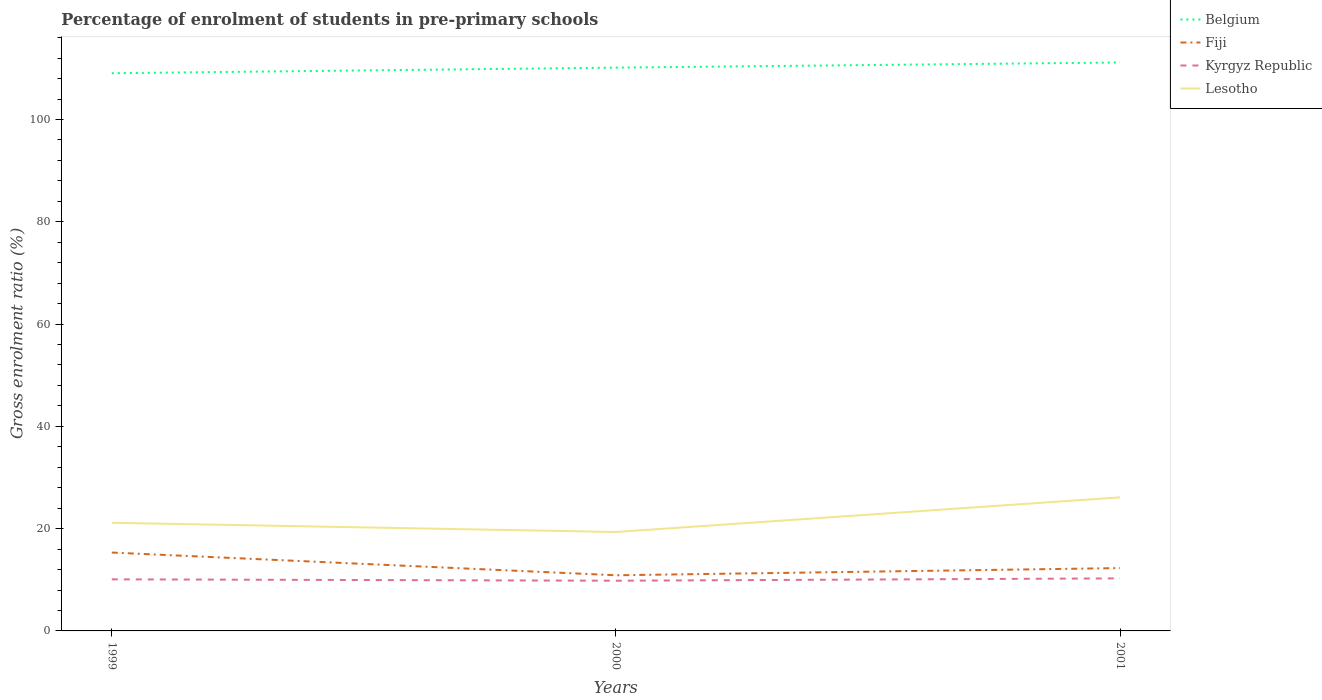How many different coloured lines are there?
Your response must be concise. 4. Is the number of lines equal to the number of legend labels?
Offer a terse response. Yes. Across all years, what is the maximum percentage of students enrolled in pre-primary schools in Lesotho?
Keep it short and to the point. 19.34. In which year was the percentage of students enrolled in pre-primary schools in Belgium maximum?
Your answer should be very brief. 1999. What is the total percentage of students enrolled in pre-primary schools in Fiji in the graph?
Provide a succinct answer. -1.41. What is the difference between the highest and the second highest percentage of students enrolled in pre-primary schools in Kyrgyz Republic?
Make the answer very short. 0.46. What is the difference between the highest and the lowest percentage of students enrolled in pre-primary schools in Lesotho?
Your answer should be very brief. 1. Is the percentage of students enrolled in pre-primary schools in Belgium strictly greater than the percentage of students enrolled in pre-primary schools in Fiji over the years?
Keep it short and to the point. No. How many lines are there?
Ensure brevity in your answer.  4. What is the difference between two consecutive major ticks on the Y-axis?
Provide a short and direct response. 20. Are the values on the major ticks of Y-axis written in scientific E-notation?
Offer a very short reply. No. How many legend labels are there?
Your response must be concise. 4. What is the title of the graph?
Your response must be concise. Percentage of enrolment of students in pre-primary schools. Does "Hong Kong" appear as one of the legend labels in the graph?
Your answer should be very brief. No. What is the label or title of the Y-axis?
Provide a succinct answer. Gross enrolment ratio (%). What is the Gross enrolment ratio (%) in Belgium in 1999?
Offer a terse response. 109.05. What is the Gross enrolment ratio (%) of Fiji in 1999?
Your answer should be very brief. 15.32. What is the Gross enrolment ratio (%) of Kyrgyz Republic in 1999?
Your response must be concise. 10.09. What is the Gross enrolment ratio (%) of Lesotho in 1999?
Provide a short and direct response. 21.15. What is the Gross enrolment ratio (%) of Belgium in 2000?
Give a very brief answer. 110.14. What is the Gross enrolment ratio (%) of Fiji in 2000?
Your answer should be compact. 10.88. What is the Gross enrolment ratio (%) of Kyrgyz Republic in 2000?
Provide a succinct answer. 9.82. What is the Gross enrolment ratio (%) in Lesotho in 2000?
Offer a terse response. 19.34. What is the Gross enrolment ratio (%) of Belgium in 2001?
Your answer should be very brief. 111.14. What is the Gross enrolment ratio (%) in Fiji in 2001?
Make the answer very short. 12.29. What is the Gross enrolment ratio (%) of Kyrgyz Republic in 2001?
Your answer should be very brief. 10.28. What is the Gross enrolment ratio (%) of Lesotho in 2001?
Your response must be concise. 26.12. Across all years, what is the maximum Gross enrolment ratio (%) in Belgium?
Keep it short and to the point. 111.14. Across all years, what is the maximum Gross enrolment ratio (%) of Fiji?
Your answer should be compact. 15.32. Across all years, what is the maximum Gross enrolment ratio (%) in Kyrgyz Republic?
Offer a very short reply. 10.28. Across all years, what is the maximum Gross enrolment ratio (%) of Lesotho?
Your response must be concise. 26.12. Across all years, what is the minimum Gross enrolment ratio (%) in Belgium?
Provide a short and direct response. 109.05. Across all years, what is the minimum Gross enrolment ratio (%) in Fiji?
Your response must be concise. 10.88. Across all years, what is the minimum Gross enrolment ratio (%) of Kyrgyz Republic?
Keep it short and to the point. 9.82. Across all years, what is the minimum Gross enrolment ratio (%) in Lesotho?
Provide a short and direct response. 19.34. What is the total Gross enrolment ratio (%) in Belgium in the graph?
Provide a succinct answer. 330.33. What is the total Gross enrolment ratio (%) in Fiji in the graph?
Give a very brief answer. 38.49. What is the total Gross enrolment ratio (%) of Kyrgyz Republic in the graph?
Your answer should be compact. 30.18. What is the total Gross enrolment ratio (%) in Lesotho in the graph?
Provide a succinct answer. 66.6. What is the difference between the Gross enrolment ratio (%) of Belgium in 1999 and that in 2000?
Ensure brevity in your answer.  -1.09. What is the difference between the Gross enrolment ratio (%) of Fiji in 1999 and that in 2000?
Give a very brief answer. 4.44. What is the difference between the Gross enrolment ratio (%) of Kyrgyz Republic in 1999 and that in 2000?
Your response must be concise. 0.27. What is the difference between the Gross enrolment ratio (%) of Lesotho in 1999 and that in 2000?
Give a very brief answer. 1.8. What is the difference between the Gross enrolment ratio (%) of Belgium in 1999 and that in 2001?
Make the answer very short. -2.1. What is the difference between the Gross enrolment ratio (%) in Fiji in 1999 and that in 2001?
Ensure brevity in your answer.  3.04. What is the difference between the Gross enrolment ratio (%) of Kyrgyz Republic in 1999 and that in 2001?
Offer a terse response. -0.19. What is the difference between the Gross enrolment ratio (%) in Lesotho in 1999 and that in 2001?
Make the answer very short. -4.97. What is the difference between the Gross enrolment ratio (%) of Belgium in 2000 and that in 2001?
Your answer should be very brief. -1.01. What is the difference between the Gross enrolment ratio (%) in Fiji in 2000 and that in 2001?
Your answer should be very brief. -1.41. What is the difference between the Gross enrolment ratio (%) in Kyrgyz Republic in 2000 and that in 2001?
Make the answer very short. -0.46. What is the difference between the Gross enrolment ratio (%) in Lesotho in 2000 and that in 2001?
Your response must be concise. -6.77. What is the difference between the Gross enrolment ratio (%) in Belgium in 1999 and the Gross enrolment ratio (%) in Fiji in 2000?
Give a very brief answer. 98.16. What is the difference between the Gross enrolment ratio (%) in Belgium in 1999 and the Gross enrolment ratio (%) in Kyrgyz Republic in 2000?
Your response must be concise. 99.23. What is the difference between the Gross enrolment ratio (%) in Belgium in 1999 and the Gross enrolment ratio (%) in Lesotho in 2000?
Keep it short and to the point. 89.7. What is the difference between the Gross enrolment ratio (%) of Fiji in 1999 and the Gross enrolment ratio (%) of Kyrgyz Republic in 2000?
Make the answer very short. 5.51. What is the difference between the Gross enrolment ratio (%) of Fiji in 1999 and the Gross enrolment ratio (%) of Lesotho in 2000?
Offer a very short reply. -4.02. What is the difference between the Gross enrolment ratio (%) in Kyrgyz Republic in 1999 and the Gross enrolment ratio (%) in Lesotho in 2000?
Give a very brief answer. -9.25. What is the difference between the Gross enrolment ratio (%) of Belgium in 1999 and the Gross enrolment ratio (%) of Fiji in 2001?
Give a very brief answer. 96.76. What is the difference between the Gross enrolment ratio (%) of Belgium in 1999 and the Gross enrolment ratio (%) of Kyrgyz Republic in 2001?
Provide a succinct answer. 98.77. What is the difference between the Gross enrolment ratio (%) of Belgium in 1999 and the Gross enrolment ratio (%) of Lesotho in 2001?
Provide a succinct answer. 82.93. What is the difference between the Gross enrolment ratio (%) in Fiji in 1999 and the Gross enrolment ratio (%) in Kyrgyz Republic in 2001?
Your response must be concise. 5.05. What is the difference between the Gross enrolment ratio (%) in Fiji in 1999 and the Gross enrolment ratio (%) in Lesotho in 2001?
Ensure brevity in your answer.  -10.79. What is the difference between the Gross enrolment ratio (%) in Kyrgyz Republic in 1999 and the Gross enrolment ratio (%) in Lesotho in 2001?
Your answer should be very brief. -16.03. What is the difference between the Gross enrolment ratio (%) in Belgium in 2000 and the Gross enrolment ratio (%) in Fiji in 2001?
Offer a terse response. 97.85. What is the difference between the Gross enrolment ratio (%) in Belgium in 2000 and the Gross enrolment ratio (%) in Kyrgyz Republic in 2001?
Your answer should be very brief. 99.86. What is the difference between the Gross enrolment ratio (%) of Belgium in 2000 and the Gross enrolment ratio (%) of Lesotho in 2001?
Give a very brief answer. 84.02. What is the difference between the Gross enrolment ratio (%) of Fiji in 2000 and the Gross enrolment ratio (%) of Kyrgyz Republic in 2001?
Give a very brief answer. 0.6. What is the difference between the Gross enrolment ratio (%) in Fiji in 2000 and the Gross enrolment ratio (%) in Lesotho in 2001?
Ensure brevity in your answer.  -15.23. What is the difference between the Gross enrolment ratio (%) in Kyrgyz Republic in 2000 and the Gross enrolment ratio (%) in Lesotho in 2001?
Keep it short and to the point. -16.3. What is the average Gross enrolment ratio (%) of Belgium per year?
Offer a terse response. 110.11. What is the average Gross enrolment ratio (%) of Fiji per year?
Keep it short and to the point. 12.83. What is the average Gross enrolment ratio (%) in Kyrgyz Republic per year?
Provide a succinct answer. 10.06. What is the average Gross enrolment ratio (%) in Lesotho per year?
Ensure brevity in your answer.  22.2. In the year 1999, what is the difference between the Gross enrolment ratio (%) in Belgium and Gross enrolment ratio (%) in Fiji?
Offer a terse response. 93.72. In the year 1999, what is the difference between the Gross enrolment ratio (%) in Belgium and Gross enrolment ratio (%) in Kyrgyz Republic?
Offer a very short reply. 98.96. In the year 1999, what is the difference between the Gross enrolment ratio (%) of Belgium and Gross enrolment ratio (%) of Lesotho?
Your answer should be very brief. 87.9. In the year 1999, what is the difference between the Gross enrolment ratio (%) in Fiji and Gross enrolment ratio (%) in Kyrgyz Republic?
Keep it short and to the point. 5.24. In the year 1999, what is the difference between the Gross enrolment ratio (%) of Fiji and Gross enrolment ratio (%) of Lesotho?
Ensure brevity in your answer.  -5.82. In the year 1999, what is the difference between the Gross enrolment ratio (%) in Kyrgyz Republic and Gross enrolment ratio (%) in Lesotho?
Keep it short and to the point. -11.06. In the year 2000, what is the difference between the Gross enrolment ratio (%) of Belgium and Gross enrolment ratio (%) of Fiji?
Keep it short and to the point. 99.26. In the year 2000, what is the difference between the Gross enrolment ratio (%) of Belgium and Gross enrolment ratio (%) of Kyrgyz Republic?
Offer a terse response. 100.32. In the year 2000, what is the difference between the Gross enrolment ratio (%) of Belgium and Gross enrolment ratio (%) of Lesotho?
Your response must be concise. 90.8. In the year 2000, what is the difference between the Gross enrolment ratio (%) of Fiji and Gross enrolment ratio (%) of Kyrgyz Republic?
Give a very brief answer. 1.07. In the year 2000, what is the difference between the Gross enrolment ratio (%) in Fiji and Gross enrolment ratio (%) in Lesotho?
Ensure brevity in your answer.  -8.46. In the year 2000, what is the difference between the Gross enrolment ratio (%) of Kyrgyz Republic and Gross enrolment ratio (%) of Lesotho?
Make the answer very short. -9.52. In the year 2001, what is the difference between the Gross enrolment ratio (%) of Belgium and Gross enrolment ratio (%) of Fiji?
Make the answer very short. 98.86. In the year 2001, what is the difference between the Gross enrolment ratio (%) of Belgium and Gross enrolment ratio (%) of Kyrgyz Republic?
Your response must be concise. 100.87. In the year 2001, what is the difference between the Gross enrolment ratio (%) of Belgium and Gross enrolment ratio (%) of Lesotho?
Your answer should be very brief. 85.03. In the year 2001, what is the difference between the Gross enrolment ratio (%) of Fiji and Gross enrolment ratio (%) of Kyrgyz Republic?
Ensure brevity in your answer.  2.01. In the year 2001, what is the difference between the Gross enrolment ratio (%) in Fiji and Gross enrolment ratio (%) in Lesotho?
Provide a succinct answer. -13.83. In the year 2001, what is the difference between the Gross enrolment ratio (%) of Kyrgyz Republic and Gross enrolment ratio (%) of Lesotho?
Your answer should be compact. -15.84. What is the ratio of the Gross enrolment ratio (%) in Belgium in 1999 to that in 2000?
Ensure brevity in your answer.  0.99. What is the ratio of the Gross enrolment ratio (%) in Fiji in 1999 to that in 2000?
Offer a very short reply. 1.41. What is the ratio of the Gross enrolment ratio (%) of Kyrgyz Republic in 1999 to that in 2000?
Provide a succinct answer. 1.03. What is the ratio of the Gross enrolment ratio (%) in Lesotho in 1999 to that in 2000?
Offer a terse response. 1.09. What is the ratio of the Gross enrolment ratio (%) of Belgium in 1999 to that in 2001?
Offer a terse response. 0.98. What is the ratio of the Gross enrolment ratio (%) in Fiji in 1999 to that in 2001?
Your answer should be compact. 1.25. What is the ratio of the Gross enrolment ratio (%) in Kyrgyz Republic in 1999 to that in 2001?
Give a very brief answer. 0.98. What is the ratio of the Gross enrolment ratio (%) in Lesotho in 1999 to that in 2001?
Your response must be concise. 0.81. What is the ratio of the Gross enrolment ratio (%) in Belgium in 2000 to that in 2001?
Keep it short and to the point. 0.99. What is the ratio of the Gross enrolment ratio (%) of Fiji in 2000 to that in 2001?
Ensure brevity in your answer.  0.89. What is the ratio of the Gross enrolment ratio (%) of Kyrgyz Republic in 2000 to that in 2001?
Provide a short and direct response. 0.96. What is the ratio of the Gross enrolment ratio (%) of Lesotho in 2000 to that in 2001?
Ensure brevity in your answer.  0.74. What is the difference between the highest and the second highest Gross enrolment ratio (%) of Belgium?
Ensure brevity in your answer.  1.01. What is the difference between the highest and the second highest Gross enrolment ratio (%) of Fiji?
Offer a very short reply. 3.04. What is the difference between the highest and the second highest Gross enrolment ratio (%) in Kyrgyz Republic?
Make the answer very short. 0.19. What is the difference between the highest and the second highest Gross enrolment ratio (%) in Lesotho?
Give a very brief answer. 4.97. What is the difference between the highest and the lowest Gross enrolment ratio (%) of Belgium?
Provide a succinct answer. 2.1. What is the difference between the highest and the lowest Gross enrolment ratio (%) of Fiji?
Provide a succinct answer. 4.44. What is the difference between the highest and the lowest Gross enrolment ratio (%) in Kyrgyz Republic?
Offer a very short reply. 0.46. What is the difference between the highest and the lowest Gross enrolment ratio (%) in Lesotho?
Make the answer very short. 6.77. 